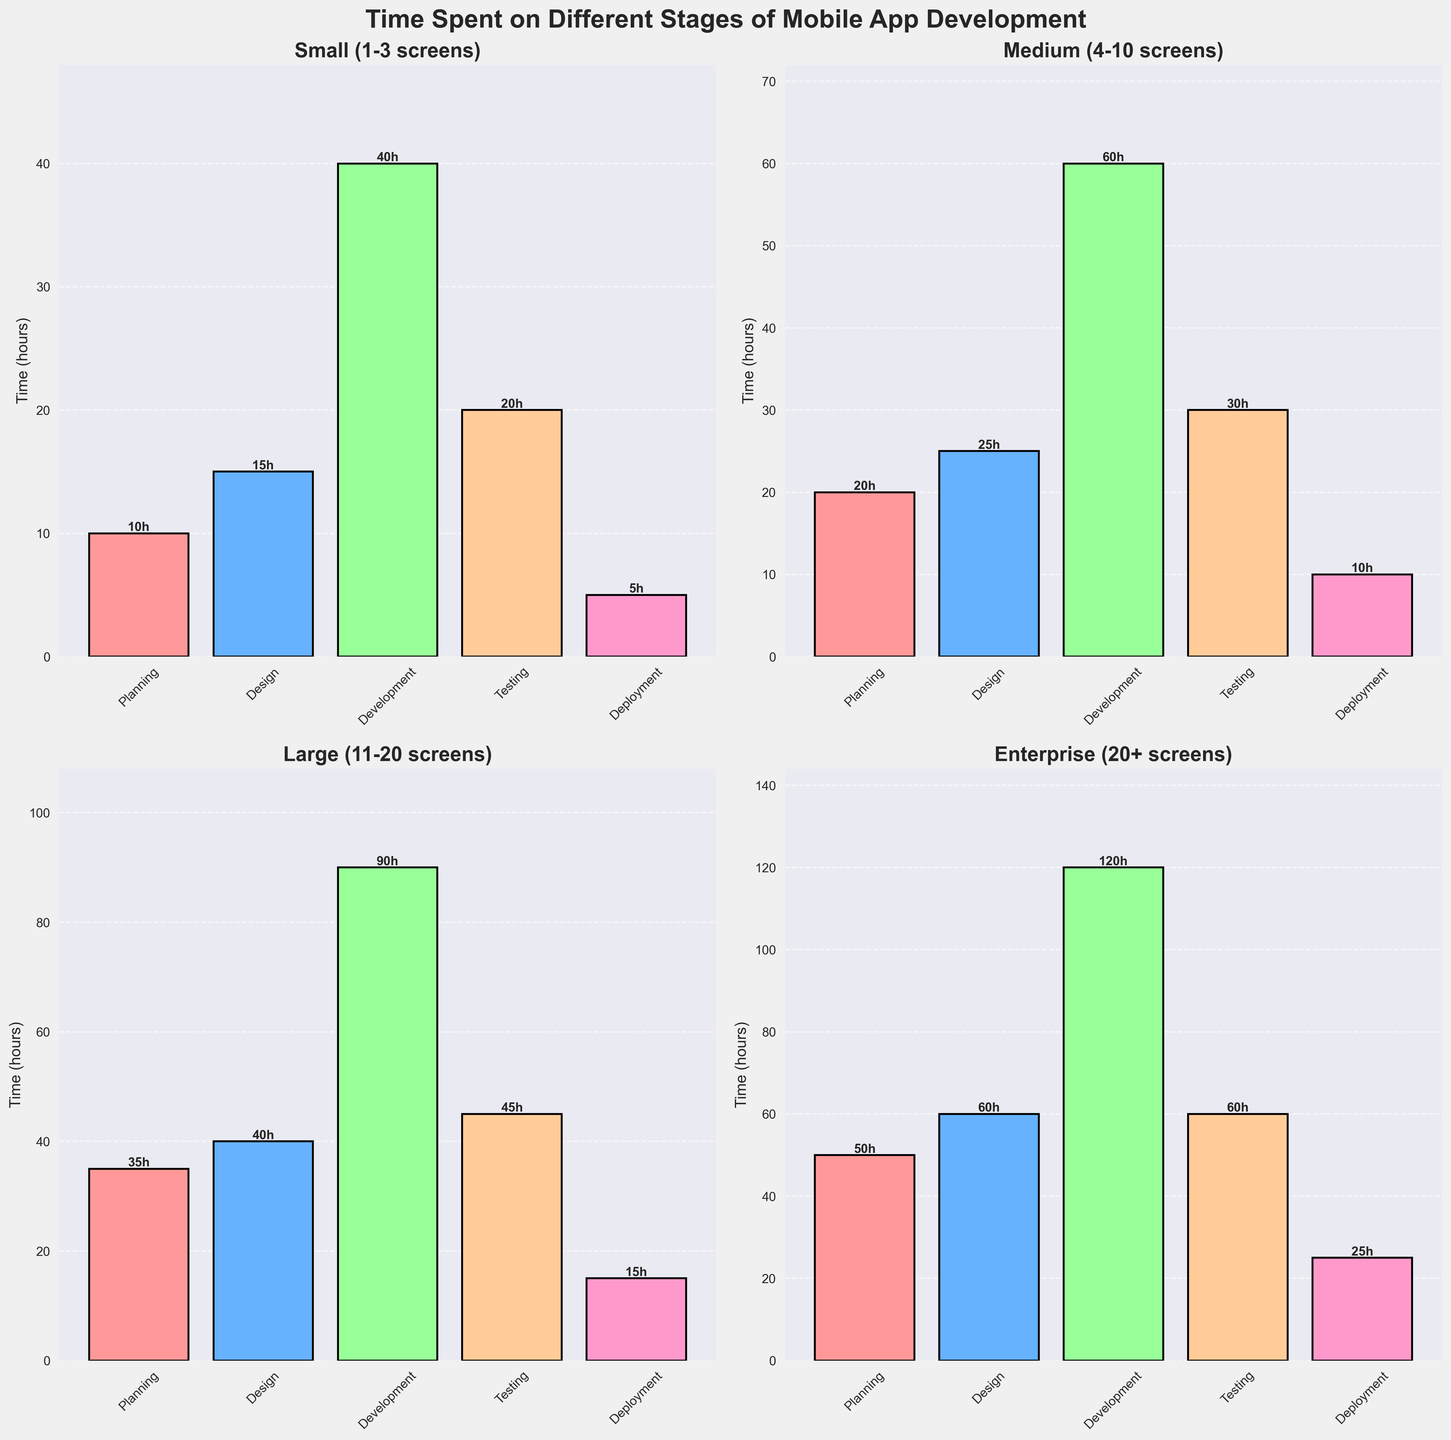Which project size spends the least time in the Development stage? Look at the bar representing Development time for each project size and compare their heights. The "Small (1-3 screens)" project size has the smallest bar in the Development stage.
Answer: Small (1-3 screens) What's the total time spent on all stages for the Enterprise project size? Add the heights of the bars (in hours) for each stage in the "Enterprise (20+ screens)" project size. The values are 50 + 60 + 120 + 60 + 25, summing them gives 315 hours.
Answer: 315 hours Which stage shows the most consistent increase in time across increasing project sizes? Examine the trend of each stage's bar height from Small to Enterprise sizes. The Development stage consistently increases: 40, 60, 90, 120 hours.
Answer: Development For the Medium project size, which stage requires the most time and which the least? Observe the bars for the "Medium (4-10 screens)" project size. The highest bar represents the Development stage at 60 hours, and the shortest is Deployment at 10 hours.
Answer: Most: Development; Least: Deployment How much more time is spent on Testing than Deployment in the Large project size? For the "Large (11-20 screens)" project size, subtract the Deployment time from the Testing time. The values are 45 hours for Testing and 15 hours for Deployment. Thus, 45 - 15 = 30 hours.
Answer: 30 hours Which project size spends the most time on Planning? Compare the heights of the Planning bars for all project sizes. The "Enterprise (20+ screens)" project size has the highest bar at 50 hours.
Answer: Enterprise (20+ screens) Approximately what percentage of the total time is spent on Design for the Small project size? Calculate the total time for the Small project size: 10 + 15 + 40 + 20 + 5 = 90 hours. The time spent on Design is 15 hours. So the percentage is (15/90) * 100 ≈ 16.67%.
Answer: ~16.67% 